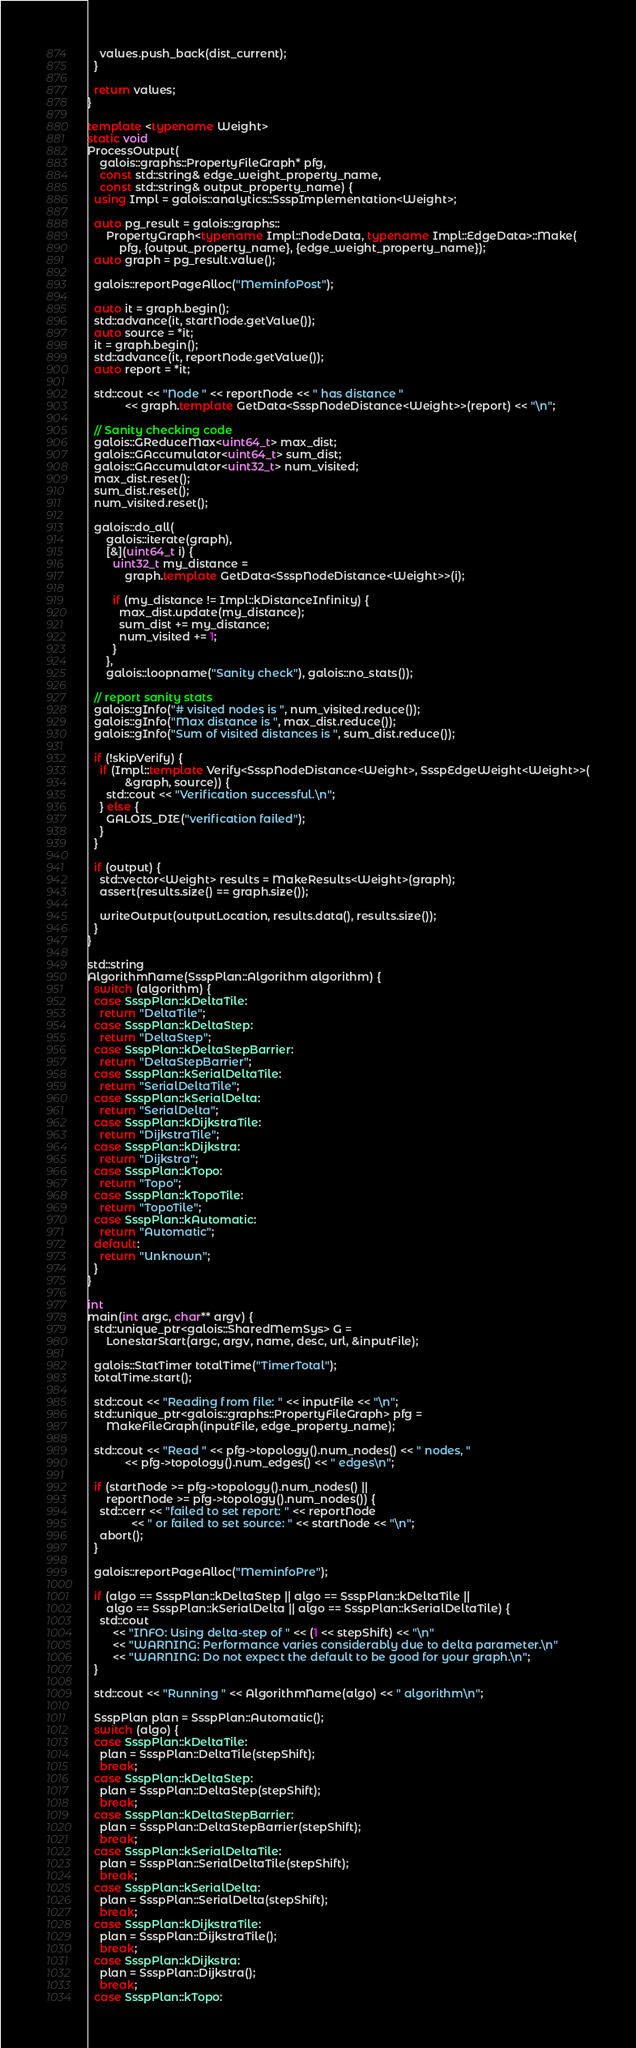Convert code to text. <code><loc_0><loc_0><loc_500><loc_500><_C++_>    values.push_back(dist_current);
  }

  return values;
}

template <typename Weight>
static void
ProcessOutput(
    galois::graphs::PropertyFileGraph* pfg,
    const std::string& edge_weight_property_name,
    const std::string& output_property_name) {
  using Impl = galois::analytics::SsspImplementation<Weight>;

  auto pg_result = galois::graphs::
      PropertyGraph<typename Impl::NodeData, typename Impl::EdgeData>::Make(
          pfg, {output_property_name}, {edge_weight_property_name});
  auto graph = pg_result.value();

  galois::reportPageAlloc("MeminfoPost");

  auto it = graph.begin();
  std::advance(it, startNode.getValue());
  auto source = *it;
  it = graph.begin();
  std::advance(it, reportNode.getValue());
  auto report = *it;

  std::cout << "Node " << reportNode << " has distance "
            << graph.template GetData<SsspNodeDistance<Weight>>(report) << "\n";

  // Sanity checking code
  galois::GReduceMax<uint64_t> max_dist;
  galois::GAccumulator<uint64_t> sum_dist;
  galois::GAccumulator<uint32_t> num_visited;
  max_dist.reset();
  sum_dist.reset();
  num_visited.reset();

  galois::do_all(
      galois::iterate(graph),
      [&](uint64_t i) {
        uint32_t my_distance =
            graph.template GetData<SsspNodeDistance<Weight>>(i);

        if (my_distance != Impl::kDistanceInfinity) {
          max_dist.update(my_distance);
          sum_dist += my_distance;
          num_visited += 1;
        }
      },
      galois::loopname("Sanity check"), galois::no_stats());

  // report sanity stats
  galois::gInfo("# visited nodes is ", num_visited.reduce());
  galois::gInfo("Max distance is ", max_dist.reduce());
  galois::gInfo("Sum of visited distances is ", sum_dist.reduce());

  if (!skipVerify) {
    if (Impl::template Verify<SsspNodeDistance<Weight>, SsspEdgeWeight<Weight>>(
            &graph, source)) {
      std::cout << "Verification successful.\n";
    } else {
      GALOIS_DIE("verification failed");
    }
  }

  if (output) {
    std::vector<Weight> results = MakeResults<Weight>(graph);
    assert(results.size() == graph.size());

    writeOutput(outputLocation, results.data(), results.size());
  }
}

std::string
AlgorithmName(SsspPlan::Algorithm algorithm) {
  switch (algorithm) {
  case SsspPlan::kDeltaTile:
    return "DeltaTile";
  case SsspPlan::kDeltaStep:
    return "DeltaStep";
  case SsspPlan::kDeltaStepBarrier:
    return "DeltaStepBarrier";
  case SsspPlan::kSerialDeltaTile:
    return "SerialDeltaTile";
  case SsspPlan::kSerialDelta:
    return "SerialDelta";
  case SsspPlan::kDijkstraTile:
    return "DijkstraTile";
  case SsspPlan::kDijkstra:
    return "Dijkstra";
  case SsspPlan::kTopo:
    return "Topo";
  case SsspPlan::kTopoTile:
    return "TopoTile";
  case SsspPlan::kAutomatic:
    return "Automatic";
  default:
    return "Unknown";
  }
}

int
main(int argc, char** argv) {
  std::unique_ptr<galois::SharedMemSys> G =
      LonestarStart(argc, argv, name, desc, url, &inputFile);

  galois::StatTimer totalTime("TimerTotal");
  totalTime.start();

  std::cout << "Reading from file: " << inputFile << "\n";
  std::unique_ptr<galois::graphs::PropertyFileGraph> pfg =
      MakeFileGraph(inputFile, edge_property_name);

  std::cout << "Read " << pfg->topology().num_nodes() << " nodes, "
            << pfg->topology().num_edges() << " edges\n";

  if (startNode >= pfg->topology().num_nodes() ||
      reportNode >= pfg->topology().num_nodes()) {
    std::cerr << "failed to set report: " << reportNode
              << " or failed to set source: " << startNode << "\n";
    abort();
  }

  galois::reportPageAlloc("MeminfoPre");

  if (algo == SsspPlan::kDeltaStep || algo == SsspPlan::kDeltaTile ||
      algo == SsspPlan::kSerialDelta || algo == SsspPlan::kSerialDeltaTile) {
    std::cout
        << "INFO: Using delta-step of " << (1 << stepShift) << "\n"
        << "WARNING: Performance varies considerably due to delta parameter.\n"
        << "WARNING: Do not expect the default to be good for your graph.\n";
  }

  std::cout << "Running " << AlgorithmName(algo) << " algorithm\n";

  SsspPlan plan = SsspPlan::Automatic();
  switch (algo) {
  case SsspPlan::kDeltaTile:
    plan = SsspPlan::DeltaTile(stepShift);
    break;
  case SsspPlan::kDeltaStep:
    plan = SsspPlan::DeltaStep(stepShift);
    break;
  case SsspPlan::kDeltaStepBarrier:
    plan = SsspPlan::DeltaStepBarrier(stepShift);
    break;
  case SsspPlan::kSerialDeltaTile:
    plan = SsspPlan::SerialDeltaTile(stepShift);
    break;
  case SsspPlan::kSerialDelta:
    plan = SsspPlan::SerialDelta(stepShift);
    break;
  case SsspPlan::kDijkstraTile:
    plan = SsspPlan::DijkstraTile();
    break;
  case SsspPlan::kDijkstra:
    plan = SsspPlan::Dijkstra();
    break;
  case SsspPlan::kTopo:</code> 